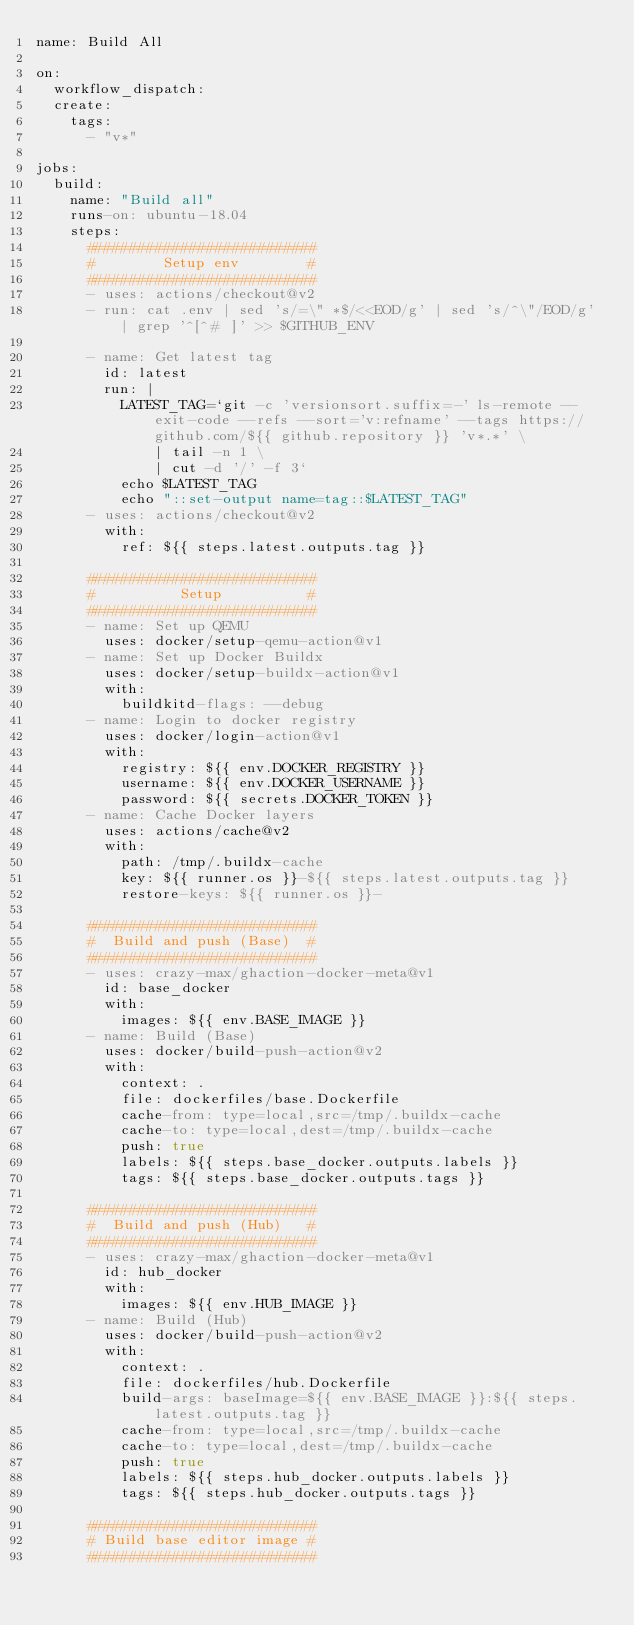<code> <loc_0><loc_0><loc_500><loc_500><_YAML_>name: Build All

on:
  workflow_dispatch:
  create:
    tags:
      - "v*"

jobs:
  build:
    name: "Build all"
    runs-on: ubuntu-18.04
    steps:
      ###########################
      #        Setup env        #
      ###########################
      - uses: actions/checkout@v2
      - run: cat .env | sed 's/=\" *$/<<EOD/g' | sed 's/^\"/EOD/g' | grep '^[^# ]' >> $GITHUB_ENV

      - name: Get latest tag
        id: latest
        run: |
          LATEST_TAG=`git -c 'versionsort.suffix=-' ls-remote --exit-code --refs --sort='v:refname' --tags https://github.com/${{ github.repository }} 'v*.*' \
              | tail -n 1 \
              | cut -d '/' -f 3`
          echo $LATEST_TAG
          echo "::set-output name=tag::$LATEST_TAG"
      - uses: actions/checkout@v2
        with:
          ref: ${{ steps.latest.outputs.tag }}

      ###########################
      #          Setup          #
      ###########################
      - name: Set up QEMU
        uses: docker/setup-qemu-action@v1
      - name: Set up Docker Buildx
        uses: docker/setup-buildx-action@v1
        with:
          buildkitd-flags: --debug
      - name: Login to docker registry
        uses: docker/login-action@v1
        with:
          registry: ${{ env.DOCKER_REGISTRY }}
          username: ${{ env.DOCKER_USERNAME }}
          password: ${{ secrets.DOCKER_TOKEN }}
      - name: Cache Docker layers
        uses: actions/cache@v2
        with:
          path: /tmp/.buildx-cache
          key: ${{ runner.os }}-${{ steps.latest.outputs.tag }}
          restore-keys: ${{ runner.os }}-

      ###########################
      #  Build and push (Base)  #
      ###########################
      - uses: crazy-max/ghaction-docker-meta@v1
        id: base_docker
        with:
          images: ${{ env.BASE_IMAGE }}
      - name: Build (Base)
        uses: docker/build-push-action@v2
        with:
          context: .
          file: dockerfiles/base.Dockerfile
          cache-from: type=local,src=/tmp/.buildx-cache
          cache-to: type=local,dest=/tmp/.buildx-cache
          push: true
          labels: ${{ steps.base_docker.outputs.labels }}
          tags: ${{ steps.base_docker.outputs.tags }}

      ###########################
      #  Build and push (Hub)   #
      ###########################
      - uses: crazy-max/ghaction-docker-meta@v1
        id: hub_docker
        with:
          images: ${{ env.HUB_IMAGE }}
      - name: Build (Hub)
        uses: docker/build-push-action@v2
        with:
          context: .
          file: dockerfiles/hub.Dockerfile
          build-args: baseImage=${{ env.BASE_IMAGE }}:${{ steps.latest.outputs.tag }}
          cache-from: type=local,src=/tmp/.buildx-cache
          cache-to: type=local,dest=/tmp/.buildx-cache
          push: true
          labels: ${{ steps.hub_docker.outputs.labels }}
          tags: ${{ steps.hub_docker.outputs.tags }}

      ###########################
      # Build base editor image #
      ###########################</code> 